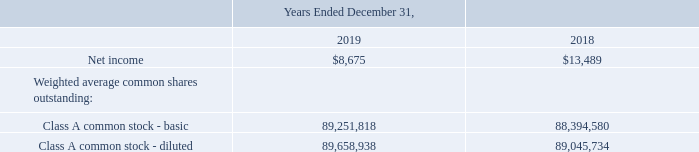Class A
As of December 31, 2019 and 2018, there were no weighted average shares of unvested Class A restricted common stock shares considered to be participating securities.
The computation of diluted earnings per share assumes the issuance of common stock for all potentially dilutive stock options and restricted stock units not classified as participating securities.
As of December 31, 2019, there were 1,718,865 shares of Class A restricted stock units and 1,478,756 Class A stock options outstanding and considered to be potentially dilutive securities. As of December 31, 2018, there were 912,315 shares of Class A restricted stock units and 866,011 Class A stock options outstanding and considered to be potentially dilutive securities.
The components of the calculation of basic earnings per share and diluted earnings per share are as follows:
For annual earnings per share calculations, there were 407,120 and 651,154 dilutive equity awards outstanding for the years ended December 31, 2019 and 2018. Awards of 920,845 and 469,112 shares of common stock for 2019 and 2018, respectively, were not included in the computation of diluted earnings per share because inclusion of these awards would be anti-dilutive.
Was there weighted average shares of unvested Class A restricted common stock shares considered to be participating securities as of December 31, 2019 and 2018? As of december 31, 2019 and 2018, there were no weighted average shares of unvested class a restricted common stock shares considered to be participating securities. How much was the shares of Class A restricted stock unit as of December 31, 2019? 1,718,865. How much was the shares of Class A restricted stock unit as of December 31, 2018? 912,315. What is the change in Net income from Years Ended December 31, 2018 to 2019? 8,675-13,489
Answer: -4814. What is the change in Weighted average common shares outstanding: Class A common stock – basic from Years Ended December 31, 2018 to 2019? 89,251,818-88,394,580
Answer: 857238. What is the average Net income for Years Ended December 31, 2018 to 2019? (8,675+13,489) / 2
Answer: 11082. 